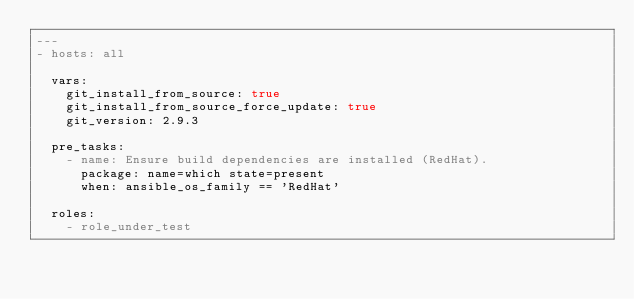Convert code to text. <code><loc_0><loc_0><loc_500><loc_500><_YAML_>---
- hosts: all

  vars:
    git_install_from_source: true
    git_install_from_source_force_update: true
    git_version: 2.9.3

  pre_tasks:
    - name: Ensure build dependencies are installed (RedHat).
      package: name=which state=present
      when: ansible_os_family == 'RedHat'

  roles:
    - role_under_test
</code> 